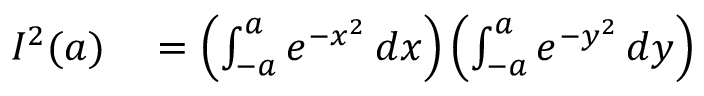Convert formula to latex. <formula><loc_0><loc_0><loc_500><loc_500>\begin{array} { r l } { I ^ { 2 } ( a ) } & = \left ( \int _ { - a } ^ { a } e ^ { - x ^ { 2 } } \, d x \right ) \left ( \int _ { - a } ^ { a } e ^ { - y ^ { 2 } } \, d y \right ) } \end{array}</formula> 